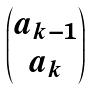Convert formula to latex. <formula><loc_0><loc_0><loc_500><loc_500>\begin{pmatrix} a _ { k - 1 } \\ a _ { k } \end{pmatrix}</formula> 